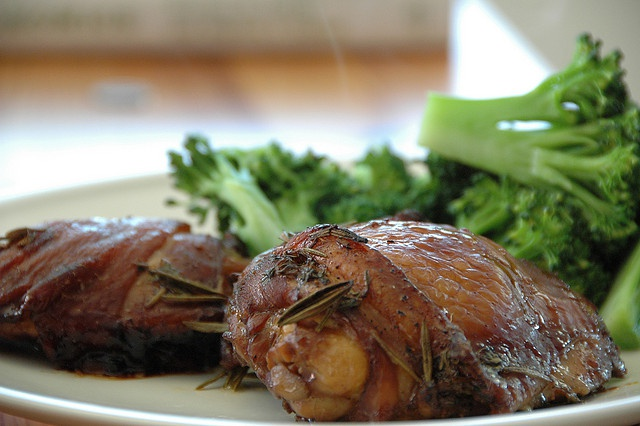Describe the objects in this image and their specific colors. I can see broccoli in gray, darkgreen, and olive tones, broccoli in gray, darkgreen, green, and darkgray tones, broccoli in gray, darkgreen, and green tones, broccoli in gray, darkgreen, and green tones, and broccoli in gray, darkgreen, and olive tones in this image. 